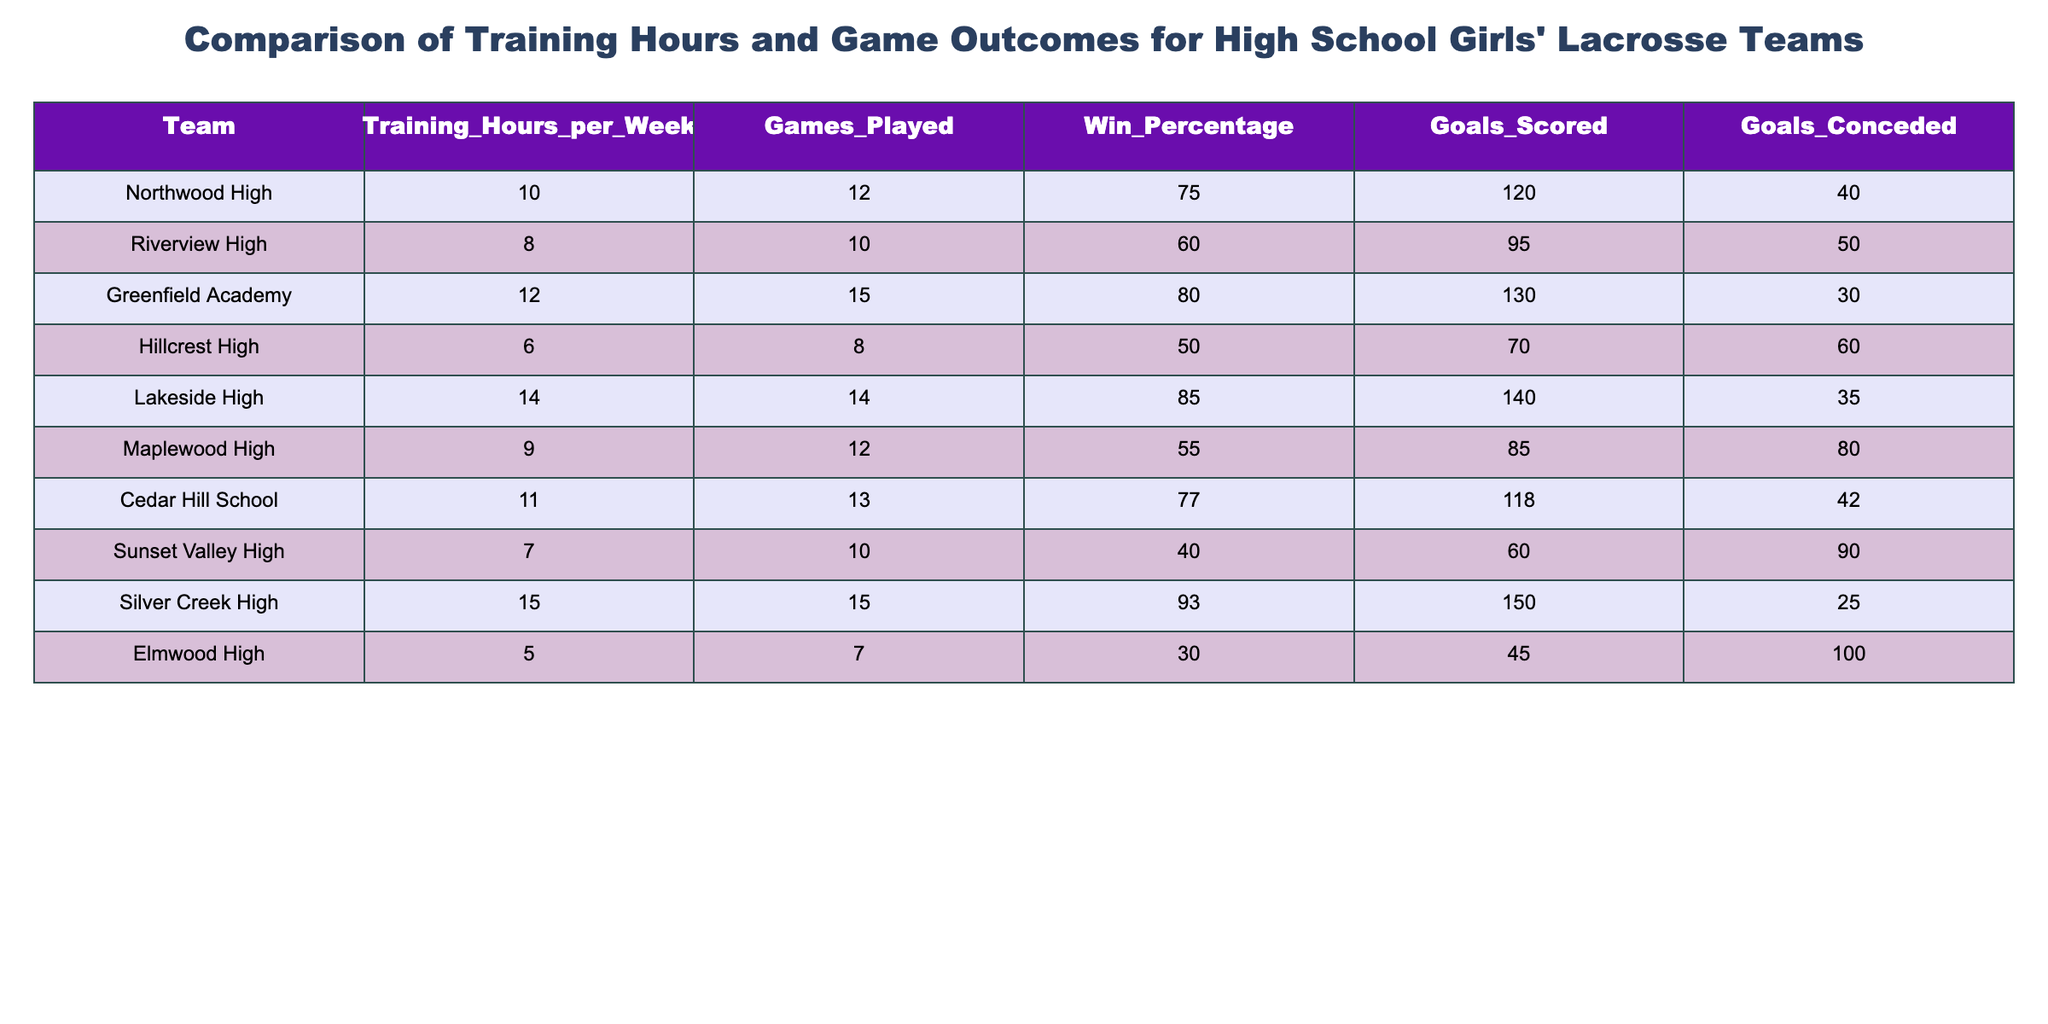What is the win percentage for Silver Creek High? The win percentage for Silver Creek High is listed directly in the table. It is found in the corresponding row for Silver Creek High under the 'Win_Percentage' column.
Answer: 93 Which team scored the highest number of goals? To find the highest number of goals scored, I look through the 'Goals_Scored' column and identify the maximum value. Checking the values, Silver Creek High scored 150 goals, which is the highest.
Answer: 150 On average, how many training hours did the teams with a win percentage over 75% train per week? First, identify the teams with a win percentage over 75%, which are Northwood High, Greenfield Academy, Lakeside High, and Silver Creek High. Their training hours are 10, 12, 14, and 15, respectively. To find the average, sum these values (10 + 12 + 14 + 15 = 51) and divide by the number of teams (4). Therefore, the average training hours is 51 / 4 = 12.75.
Answer: 12.75 Did Elmwood High have a win percentage greater than 30%? Looking at Elmwood High's row in the 'Win_Percentage' column, its value is 30%. Since the question asks whether it is greater than 30%, this is false.
Answer: No Which team has the lowest goals conceded? To determine the team with the lowest goals conceded, I need to examine the 'Goals_Conceded' column and identify the minimum value. The smallest value is found in the row for Silver Creek High, where it conceded 25 goals.
Answer: 25 What is the total number of games played by teams with more than 10 training hours per week? First, identify the teams training more than 10 hours per week, which are Greenfield Academy, Lakeside High, Cedar Hill School, and Silver Creek High, corresponding to 12, 14, 11, and 15 training hours. Next, sum their games played: 15 + 14 + 13 + 15 = 57. Thus, the total number of games played is 57.
Answer: 57 Is it true that more training hours lead to a higher win percentage? This question requires analyzing the training hours and win percentages for the teams. By comparing, one can see that although teams with higher training hours generally have higher win percentages, it is not definitively true as there are exceptions. Therefore, this statement cannot be confirmed without exception.
Answer: No What is the difference in goals scored between the team with the highest and lowest goals scored? Identifying the highest goals scored (Silver Creek High with 150) and the lowest (Elmwood High with 45), the difference is calculated by subtracting the latter from the former: 150 - 45 = 105.
Answer: 105 